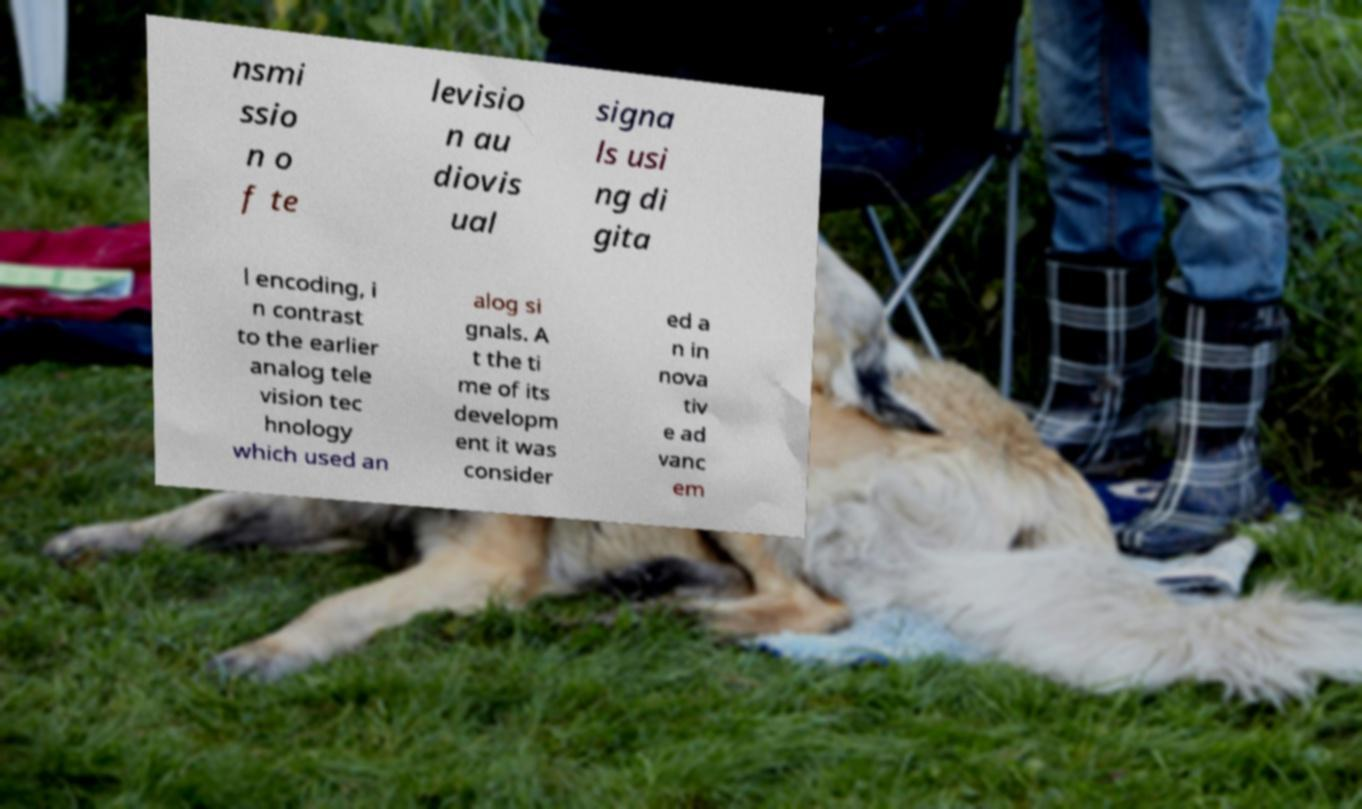For documentation purposes, I need the text within this image transcribed. Could you provide that? nsmi ssio n o f te levisio n au diovis ual signa ls usi ng di gita l encoding, i n contrast to the earlier analog tele vision tec hnology which used an alog si gnals. A t the ti me of its developm ent it was consider ed a n in nova tiv e ad vanc em 